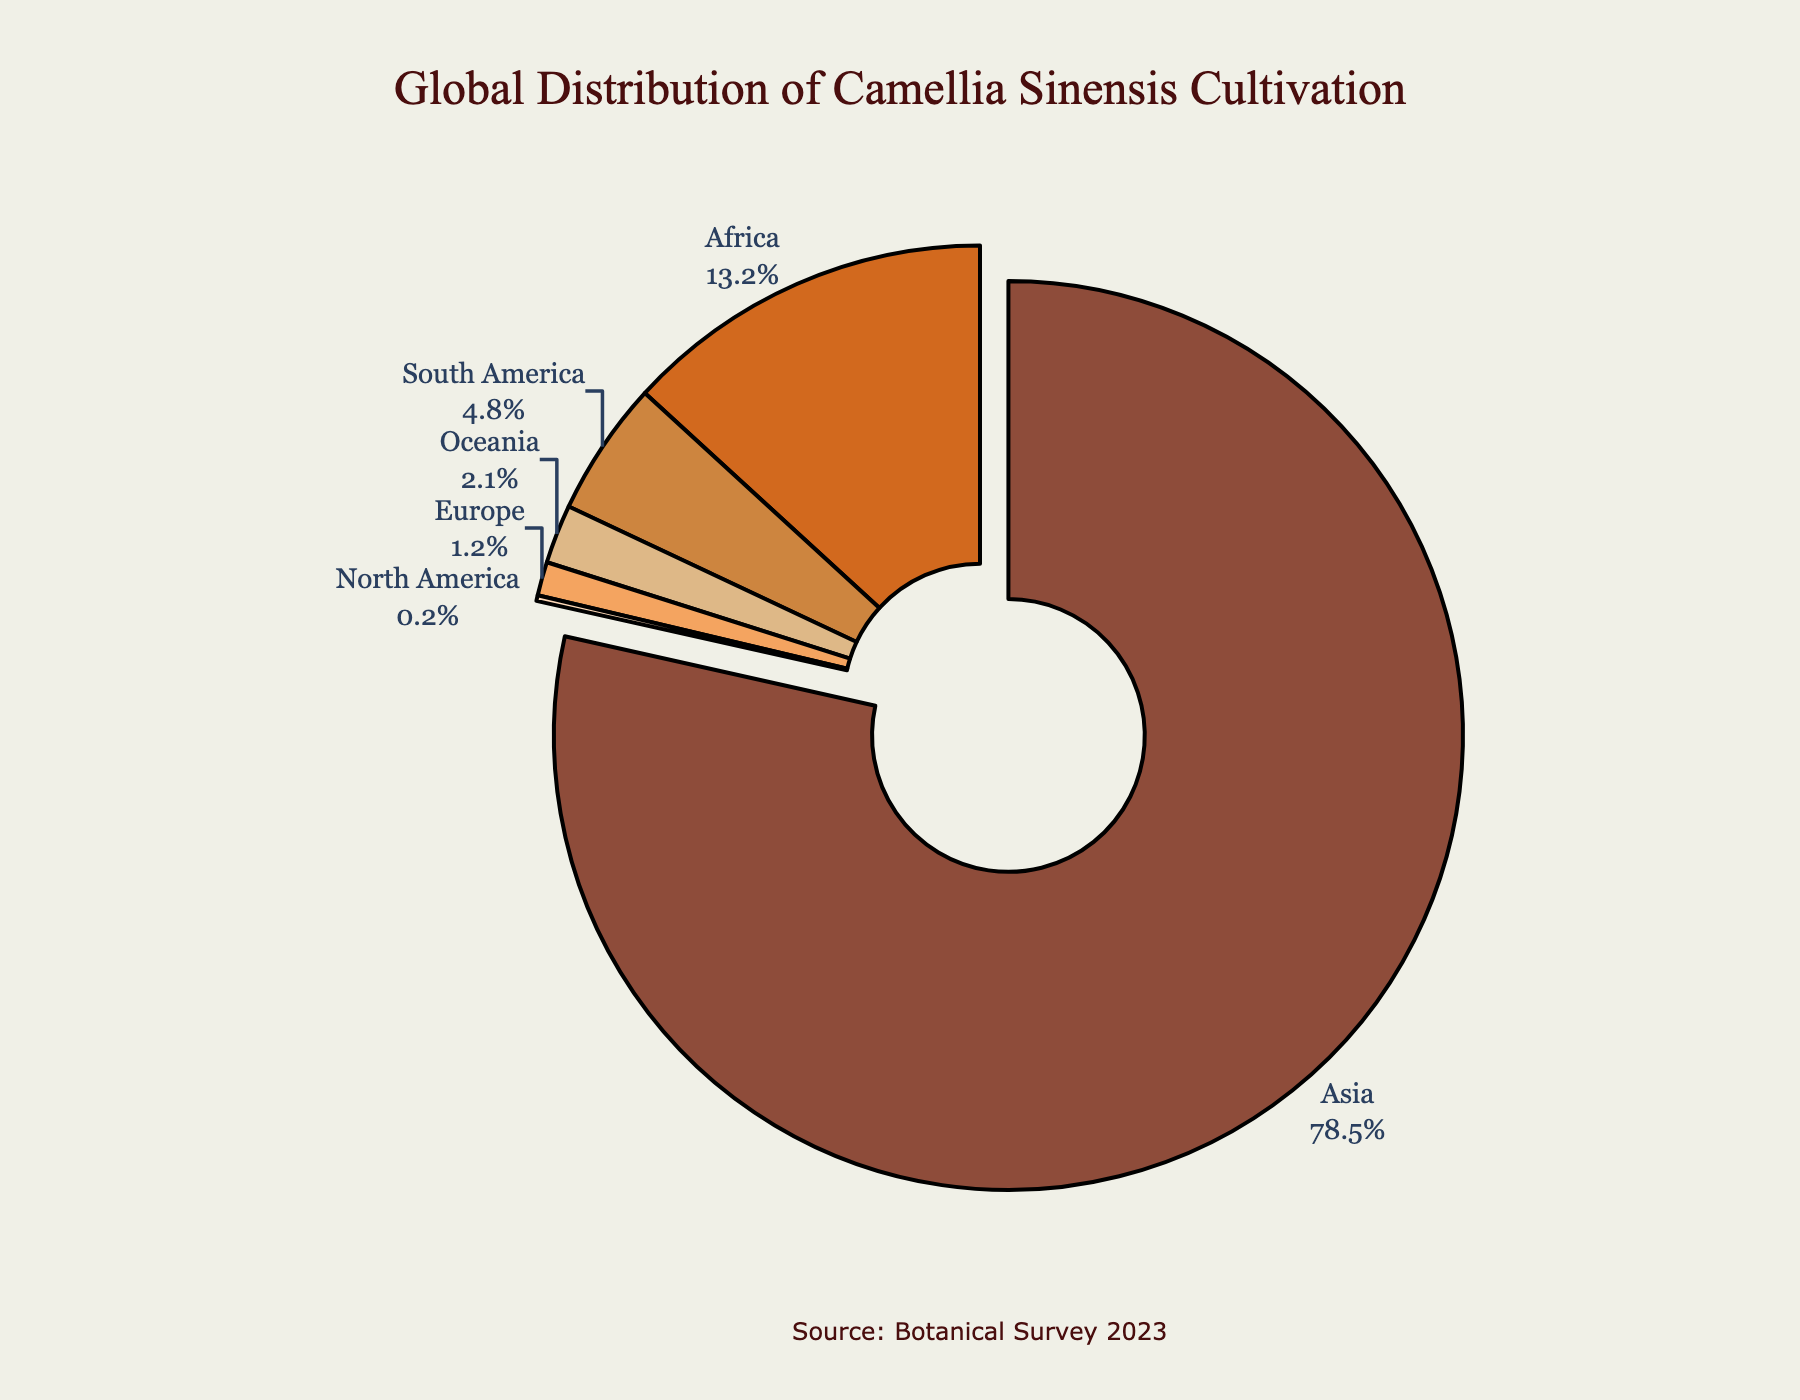Which continent has the highest percentage of Camellia Sinensis cultivation? Asia has the highest percentage of Camellia Sinensis cultivation. In the pie chart, Asia's segment is pulled out slightly to indicate its dominance.
Answer: Asia Which two continents combined have a greater percentage of Camellia Sinensis cultivation than South America? Africa and Oceania, when combined, have a greater percentage than South America. Adding Africa's 13.2% with Oceania's 2.1% gives 15.3%, which is greater than South America's 4.8%.
Answer: Africa and Oceania What is the total percentage of Camellia Sinensis cultivation in continents other than Asia? To find the total percentage for continents other than Asia, sum the percentages: 13.2% (Africa) + 4.8% (South America) + 2.1% (Oceania) + 1.2% (Europe) + 0.2% (North America) = 21.5%.
Answer: 21.5% Which continent has the smallest percentage of Camellia Sinensis cultivation, and what is that percentage? North America has the smallest percentage of Camellia Sinensis cultivation, representing only 0.2% of the global total.
Answer: North America, 0.2% How much larger is the percentage of Camellia Sinensis cultivation in Asia compared to Europe? Subtract the percentage of Europe (1.2%) from Asia (78.5%) to determine the difference: 78.5% - 1.2% = 77.3%.
Answer: 77.3% Summing Africa and South America's percentages of Camellia Sinensis cultivation, does their total exceed 15%? Summing Africa's 13.2% and South America’s 4.8% results in 18%, which exceeds 15%.
Answer: Yes, 18% Does Oceania or Europe have a higher percentage of Camellia Sinensis cultivation, and by how much? Oceania has a higher percentage than Europe. Subtract Europe's 1.2% from Oceania's 2.1% to find the difference: 2.1% - 1.2% = 0.9%.
Answer: Oceania by 0.9% What percentage of Camellia Sinensis cultivation is accounted for by continents other than Asia and Africa? Subtract the combined percentage of Asia (78.5%) and Africa (13.2%) from 100% to find the remainder: 100% - (78.5% + 13.2%) = 8.3%.
Answer: 8.3% If you combine Oceania and Europe, how does their total percentage compare to South America's? Combining the percentages of Oceania (2.1%) and Europe (1.2%) gives 3.3%. Comparing this with South America's 4.8%, South America has a higher percentage.
Answer: South America has a higher percentage What percentage difference is there between Africa and South America in terms of Camellia Sinensis cultivation? Subtract South America’s percentage (4.8%) from Africa’s percentage (13.2%): 13.2% - 4.8% = 8.4%.
Answer: 8.4% 